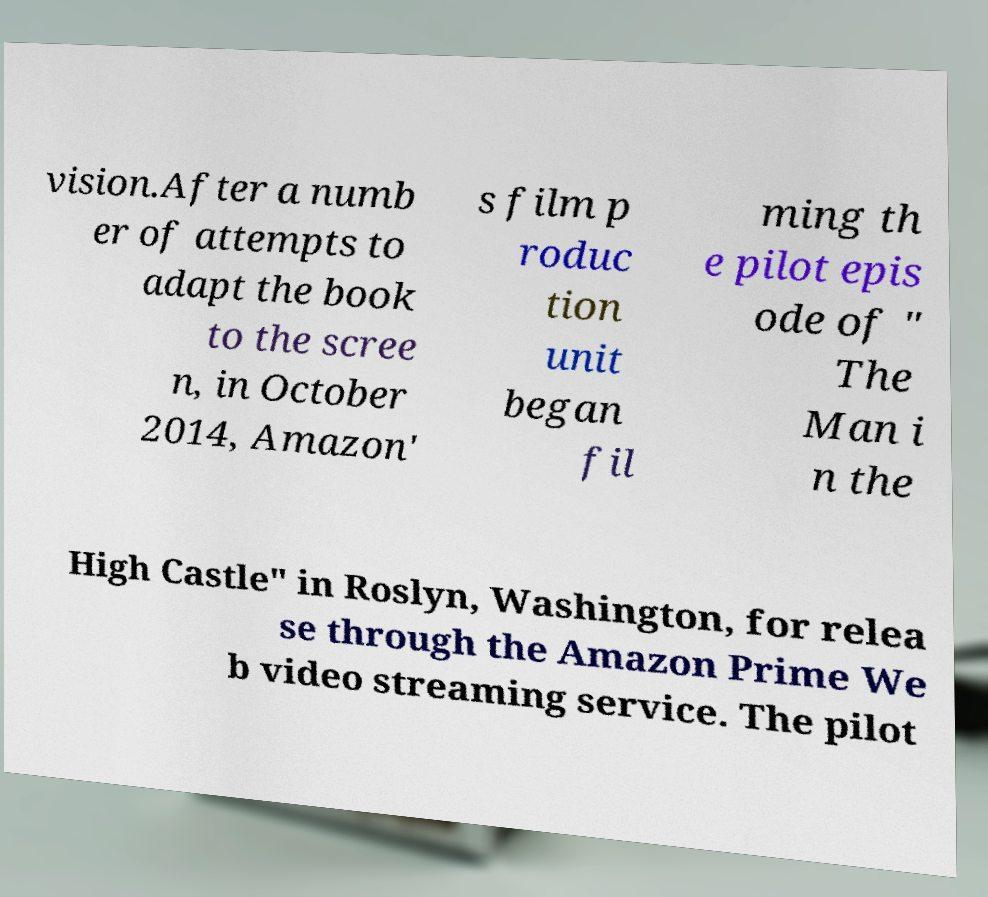Please read and relay the text visible in this image. What does it say? vision.After a numb er of attempts to adapt the book to the scree n, in October 2014, Amazon' s film p roduc tion unit began fil ming th e pilot epis ode of " The Man i n the High Castle" in Roslyn, Washington, for relea se through the Amazon Prime We b video streaming service. The pilot 